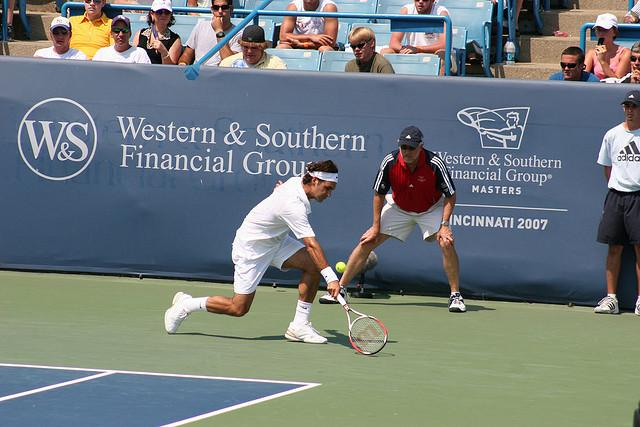When was the advertised company founded?

Choices:
A) 2000
B) 1990
C) 2007
D) 1888 1888 